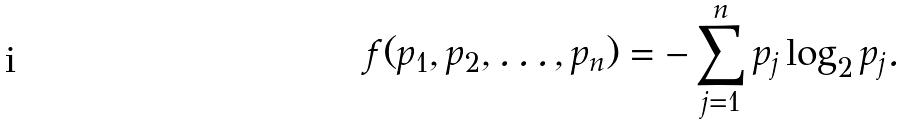<formula> <loc_0><loc_0><loc_500><loc_500>f ( p _ { 1 } , p _ { 2 } , \dots , p _ { n } ) = - \sum _ { j = 1 } ^ { n } p _ { j } \log _ { 2 } p _ { j } .</formula> 